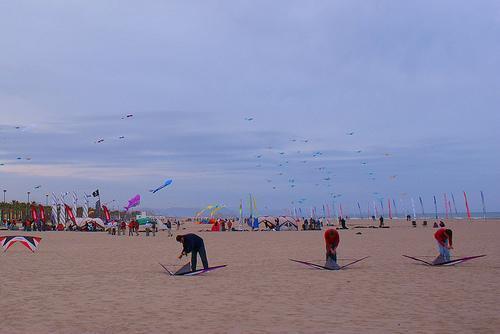How many people are close to the camera?
Give a very brief answer. 3. 